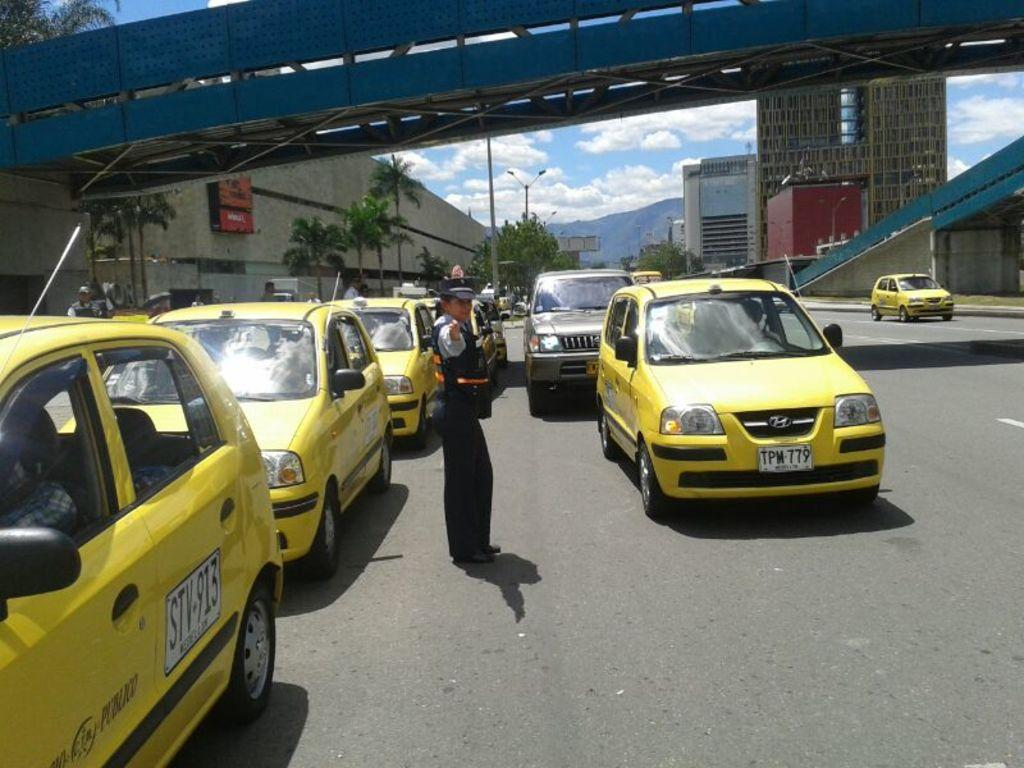<image>
Give a short and clear explanation of the subsequent image. Some Publico taxis are in a traffic jam while an officer is directing the traffic. 